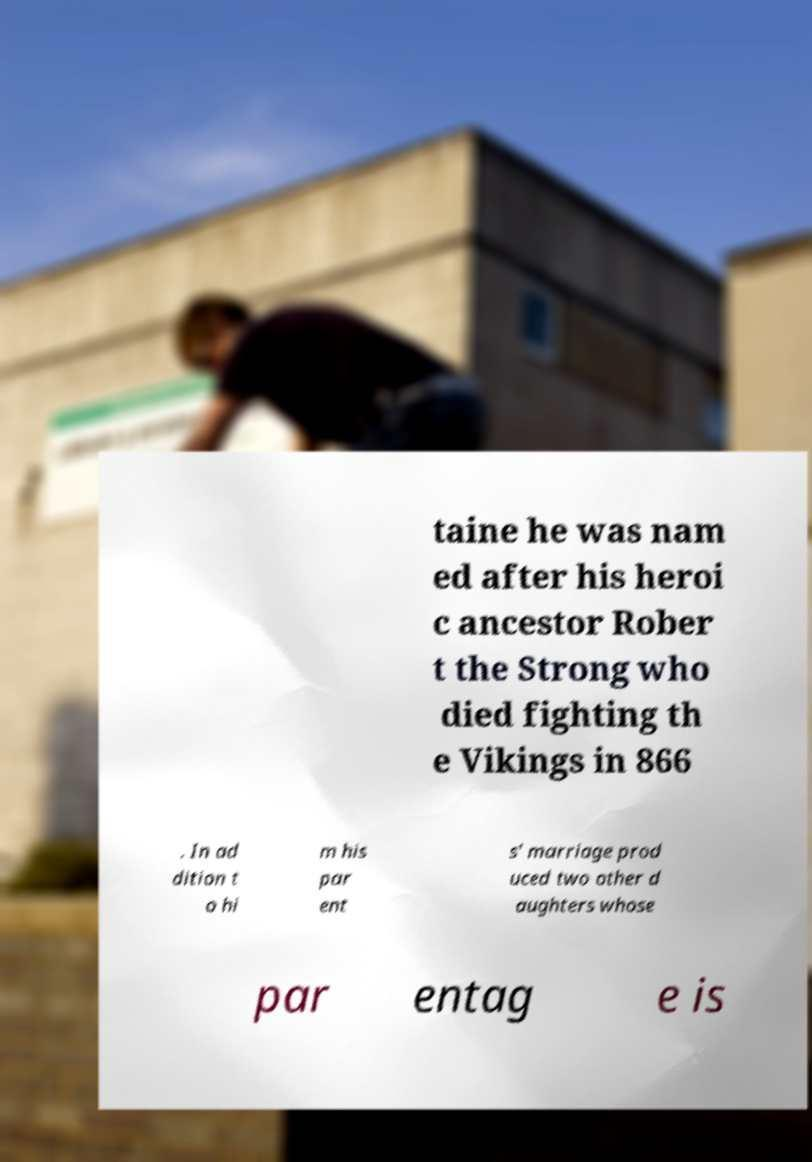Please read and relay the text visible in this image. What does it say? taine he was nam ed after his heroi c ancestor Rober t the Strong who died fighting th e Vikings in 866 . In ad dition t o hi m his par ent s' marriage prod uced two other d aughters whose par entag e is 